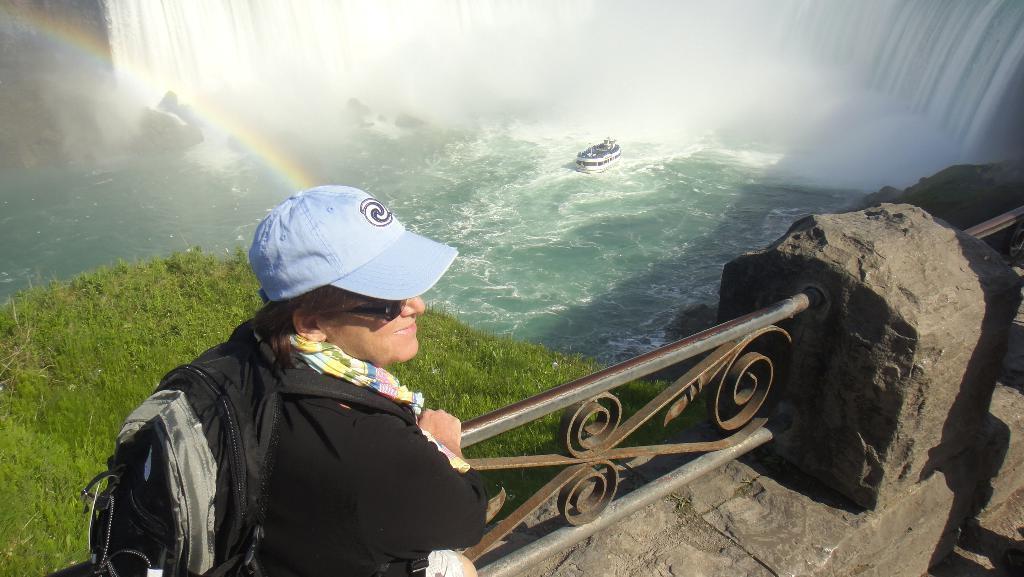Describe this image in one or two sentences. In this image I can see a person standing and wearing black jacket and black color bag. Background I can see the grass in green color, a boat on the water and the boat is in white color. 